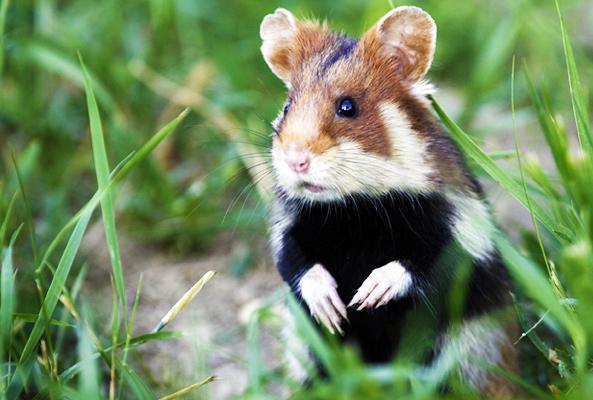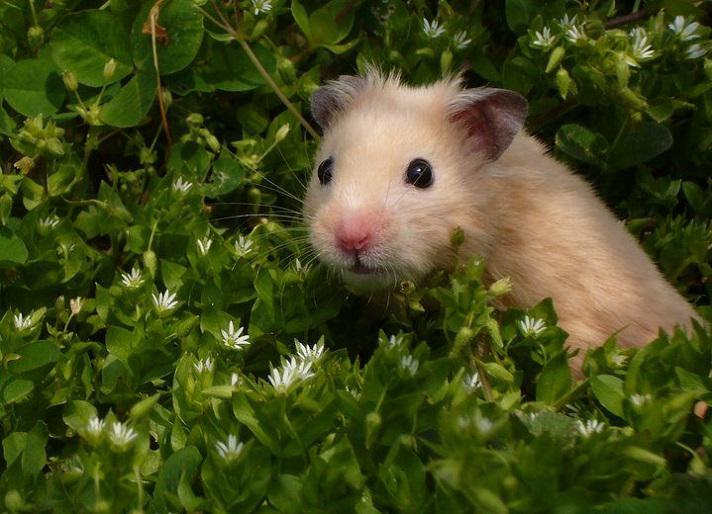The first image is the image on the left, the second image is the image on the right. Given the left and right images, does the statement "the mouse on the left image is eating something" hold true? Answer yes or no. No. 